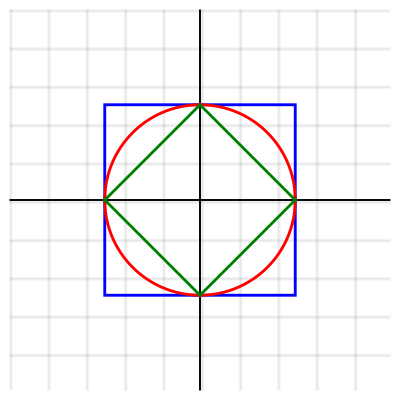In Byzantine mosaics, geometric patterns often exhibit various symmetry properties. Consider the diagram above, which represents a simplified mosaic pattern. Identify the number of distinct symmetry operations (including the identity) that would leave this pattern unchanged, and express your answer in terms of the dihedral group $D_n$. What is the value of $n$? To solve this problem, we need to analyze the symmetry operations of the given pattern:

1. First, observe that the pattern consists of a square (blue), a circle (red), and a rhombus (green) centered at the origin.

2. Rotational symmetry:
   - The pattern remains unchanged when rotated by 90°, 180°, 270°, and 360° (identity).
   - This gives us 4 rotational symmetries.

3. Reflection symmetry:
   - The pattern has 4 lines of reflection symmetry:
     a) Vertical line (y-axis)
     b) Horizontal line (x-axis)
     c) Two diagonal lines (y = x and y = -x)
   - This gives us 4 reflection symmetries.

4. Total number of symmetry operations:
   - 4 rotations + 4 reflections = 8 symmetry operations

5. The dihedral group $D_n$ represents the symmetries of a regular n-gon.
   - It has $2n$ elements: $n$ rotations and $n$ reflections.

6. In this case, we have 8 symmetry operations, so:
   $2n = 8$
   $n = 4$

Therefore, the symmetry group of this pattern is $D_4$, which is the dihedral group of order 8.
Answer: $n = 4$ 